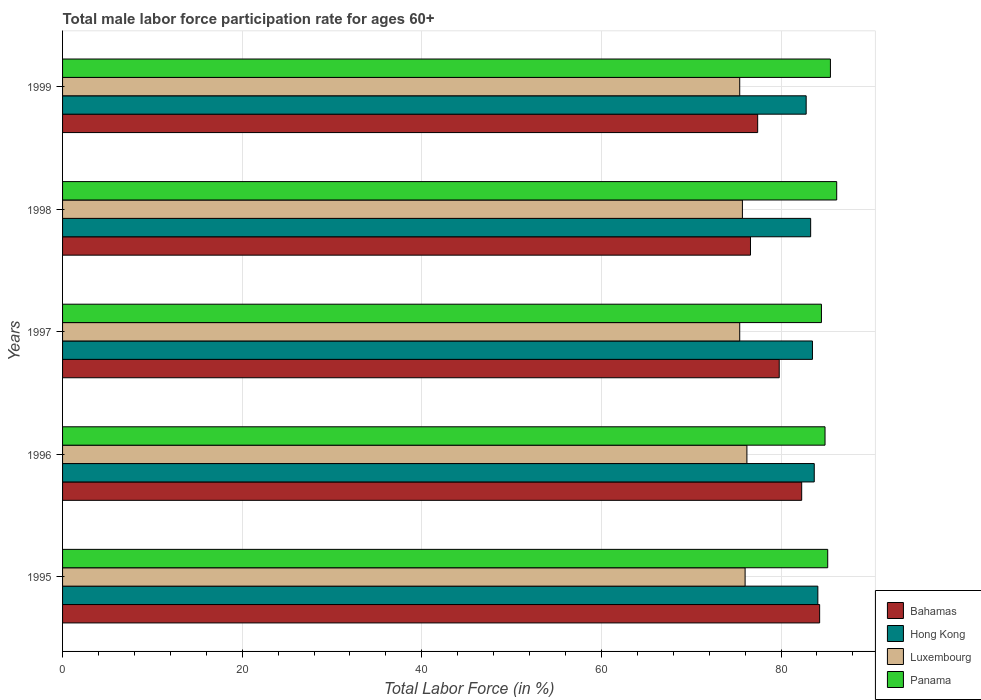How many different coloured bars are there?
Make the answer very short. 4. How many groups of bars are there?
Your answer should be very brief. 5. What is the label of the 2nd group of bars from the top?
Give a very brief answer. 1998. In how many cases, is the number of bars for a given year not equal to the number of legend labels?
Offer a very short reply. 0. What is the male labor force participation rate in Hong Kong in 1996?
Provide a short and direct response. 83.7. Across all years, what is the maximum male labor force participation rate in Hong Kong?
Offer a very short reply. 84.1. Across all years, what is the minimum male labor force participation rate in Luxembourg?
Make the answer very short. 75.4. What is the total male labor force participation rate in Panama in the graph?
Provide a short and direct response. 426.3. What is the difference between the male labor force participation rate in Bahamas in 1995 and the male labor force participation rate in Luxembourg in 1999?
Make the answer very short. 8.9. What is the average male labor force participation rate in Bahamas per year?
Ensure brevity in your answer.  80.08. In the year 1997, what is the difference between the male labor force participation rate in Luxembourg and male labor force participation rate in Bahamas?
Offer a terse response. -4.4. In how many years, is the male labor force participation rate in Panama greater than 44 %?
Provide a short and direct response. 5. What is the ratio of the male labor force participation rate in Luxembourg in 1995 to that in 1999?
Your answer should be compact. 1.01. Is the difference between the male labor force participation rate in Luxembourg in 1997 and 1998 greater than the difference between the male labor force participation rate in Bahamas in 1997 and 1998?
Your response must be concise. No. What is the difference between the highest and the second highest male labor force participation rate in Panama?
Your response must be concise. 0.7. What is the difference between the highest and the lowest male labor force participation rate in Bahamas?
Provide a succinct answer. 7.7. Is it the case that in every year, the sum of the male labor force participation rate in Luxembourg and male labor force participation rate in Hong Kong is greater than the sum of male labor force participation rate in Bahamas and male labor force participation rate in Panama?
Offer a terse response. Yes. What does the 1st bar from the top in 1995 represents?
Offer a very short reply. Panama. What does the 1st bar from the bottom in 1998 represents?
Offer a very short reply. Bahamas. Are all the bars in the graph horizontal?
Offer a very short reply. Yes. How many years are there in the graph?
Provide a short and direct response. 5. What is the difference between two consecutive major ticks on the X-axis?
Your response must be concise. 20. Does the graph contain any zero values?
Give a very brief answer. No. Does the graph contain grids?
Your answer should be very brief. Yes. Where does the legend appear in the graph?
Ensure brevity in your answer.  Bottom right. What is the title of the graph?
Offer a very short reply. Total male labor force participation rate for ages 60+. Does "Sweden" appear as one of the legend labels in the graph?
Give a very brief answer. No. What is the label or title of the X-axis?
Provide a succinct answer. Total Labor Force (in %). What is the Total Labor Force (in %) of Bahamas in 1995?
Keep it short and to the point. 84.3. What is the Total Labor Force (in %) in Hong Kong in 1995?
Offer a terse response. 84.1. What is the Total Labor Force (in %) of Panama in 1995?
Your answer should be compact. 85.2. What is the Total Labor Force (in %) of Bahamas in 1996?
Make the answer very short. 82.3. What is the Total Labor Force (in %) of Hong Kong in 1996?
Ensure brevity in your answer.  83.7. What is the Total Labor Force (in %) of Luxembourg in 1996?
Provide a succinct answer. 76.2. What is the Total Labor Force (in %) in Panama in 1996?
Make the answer very short. 84.9. What is the Total Labor Force (in %) in Bahamas in 1997?
Offer a terse response. 79.8. What is the Total Labor Force (in %) of Hong Kong in 1997?
Your answer should be compact. 83.5. What is the Total Labor Force (in %) in Luxembourg in 1997?
Your answer should be compact. 75.4. What is the Total Labor Force (in %) in Panama in 1997?
Your answer should be very brief. 84.5. What is the Total Labor Force (in %) of Bahamas in 1998?
Provide a succinct answer. 76.6. What is the Total Labor Force (in %) of Hong Kong in 1998?
Keep it short and to the point. 83.3. What is the Total Labor Force (in %) in Luxembourg in 1998?
Your response must be concise. 75.7. What is the Total Labor Force (in %) in Panama in 1998?
Ensure brevity in your answer.  86.2. What is the Total Labor Force (in %) in Bahamas in 1999?
Offer a terse response. 77.4. What is the Total Labor Force (in %) in Hong Kong in 1999?
Provide a short and direct response. 82.8. What is the Total Labor Force (in %) in Luxembourg in 1999?
Provide a short and direct response. 75.4. What is the Total Labor Force (in %) in Panama in 1999?
Ensure brevity in your answer.  85.5. Across all years, what is the maximum Total Labor Force (in %) of Bahamas?
Offer a very short reply. 84.3. Across all years, what is the maximum Total Labor Force (in %) of Hong Kong?
Your answer should be very brief. 84.1. Across all years, what is the maximum Total Labor Force (in %) in Luxembourg?
Your response must be concise. 76.2. Across all years, what is the maximum Total Labor Force (in %) in Panama?
Provide a succinct answer. 86.2. Across all years, what is the minimum Total Labor Force (in %) in Bahamas?
Provide a short and direct response. 76.6. Across all years, what is the minimum Total Labor Force (in %) in Hong Kong?
Offer a terse response. 82.8. Across all years, what is the minimum Total Labor Force (in %) in Luxembourg?
Give a very brief answer. 75.4. Across all years, what is the minimum Total Labor Force (in %) of Panama?
Provide a short and direct response. 84.5. What is the total Total Labor Force (in %) in Bahamas in the graph?
Provide a short and direct response. 400.4. What is the total Total Labor Force (in %) in Hong Kong in the graph?
Ensure brevity in your answer.  417.4. What is the total Total Labor Force (in %) in Luxembourg in the graph?
Your response must be concise. 378.7. What is the total Total Labor Force (in %) in Panama in the graph?
Keep it short and to the point. 426.3. What is the difference between the Total Labor Force (in %) of Panama in 1995 and that in 1996?
Make the answer very short. 0.3. What is the difference between the Total Labor Force (in %) of Bahamas in 1995 and that in 1997?
Give a very brief answer. 4.5. What is the difference between the Total Labor Force (in %) of Panama in 1995 and that in 1997?
Provide a succinct answer. 0.7. What is the difference between the Total Labor Force (in %) in Hong Kong in 1995 and that in 1998?
Provide a succinct answer. 0.8. What is the difference between the Total Labor Force (in %) of Bahamas in 1995 and that in 1999?
Provide a short and direct response. 6.9. What is the difference between the Total Labor Force (in %) in Hong Kong in 1995 and that in 1999?
Offer a very short reply. 1.3. What is the difference between the Total Labor Force (in %) of Panama in 1995 and that in 1999?
Keep it short and to the point. -0.3. What is the difference between the Total Labor Force (in %) in Luxembourg in 1996 and that in 1997?
Keep it short and to the point. 0.8. What is the difference between the Total Labor Force (in %) in Panama in 1996 and that in 1997?
Keep it short and to the point. 0.4. What is the difference between the Total Labor Force (in %) in Bahamas in 1996 and that in 1998?
Give a very brief answer. 5.7. What is the difference between the Total Labor Force (in %) in Luxembourg in 1996 and that in 1998?
Your answer should be compact. 0.5. What is the difference between the Total Labor Force (in %) in Panama in 1996 and that in 1998?
Make the answer very short. -1.3. What is the difference between the Total Labor Force (in %) in Panama in 1996 and that in 1999?
Your answer should be very brief. -0.6. What is the difference between the Total Labor Force (in %) in Bahamas in 1997 and that in 1998?
Your response must be concise. 3.2. What is the difference between the Total Labor Force (in %) of Hong Kong in 1997 and that in 1999?
Provide a short and direct response. 0.7. What is the difference between the Total Labor Force (in %) in Luxembourg in 1997 and that in 1999?
Make the answer very short. 0. What is the difference between the Total Labor Force (in %) of Bahamas in 1998 and that in 1999?
Offer a very short reply. -0.8. What is the difference between the Total Labor Force (in %) in Hong Kong in 1998 and that in 1999?
Ensure brevity in your answer.  0.5. What is the difference between the Total Labor Force (in %) of Bahamas in 1995 and the Total Labor Force (in %) of Hong Kong in 1996?
Keep it short and to the point. 0.6. What is the difference between the Total Labor Force (in %) in Bahamas in 1995 and the Total Labor Force (in %) in Luxembourg in 1996?
Provide a succinct answer. 8.1. What is the difference between the Total Labor Force (in %) in Bahamas in 1995 and the Total Labor Force (in %) in Panama in 1996?
Your answer should be very brief. -0.6. What is the difference between the Total Labor Force (in %) of Hong Kong in 1995 and the Total Labor Force (in %) of Luxembourg in 1996?
Your response must be concise. 7.9. What is the difference between the Total Labor Force (in %) in Bahamas in 1995 and the Total Labor Force (in %) in Hong Kong in 1997?
Provide a succinct answer. 0.8. What is the difference between the Total Labor Force (in %) of Bahamas in 1995 and the Total Labor Force (in %) of Luxembourg in 1997?
Provide a succinct answer. 8.9. What is the difference between the Total Labor Force (in %) in Hong Kong in 1995 and the Total Labor Force (in %) in Panama in 1997?
Make the answer very short. -0.4. What is the difference between the Total Labor Force (in %) in Bahamas in 1995 and the Total Labor Force (in %) in Hong Kong in 1998?
Provide a succinct answer. 1. What is the difference between the Total Labor Force (in %) of Bahamas in 1995 and the Total Labor Force (in %) of Panama in 1998?
Keep it short and to the point. -1.9. What is the difference between the Total Labor Force (in %) of Hong Kong in 1995 and the Total Labor Force (in %) of Panama in 1998?
Give a very brief answer. -2.1. What is the difference between the Total Labor Force (in %) of Luxembourg in 1995 and the Total Labor Force (in %) of Panama in 1998?
Make the answer very short. -10.2. What is the difference between the Total Labor Force (in %) of Hong Kong in 1995 and the Total Labor Force (in %) of Panama in 1999?
Keep it short and to the point. -1.4. What is the difference between the Total Labor Force (in %) in Bahamas in 1996 and the Total Labor Force (in %) in Panama in 1997?
Ensure brevity in your answer.  -2.2. What is the difference between the Total Labor Force (in %) in Hong Kong in 1996 and the Total Labor Force (in %) in Luxembourg in 1997?
Provide a succinct answer. 8.3. What is the difference between the Total Labor Force (in %) of Hong Kong in 1996 and the Total Labor Force (in %) of Panama in 1997?
Ensure brevity in your answer.  -0.8. What is the difference between the Total Labor Force (in %) in Luxembourg in 1996 and the Total Labor Force (in %) in Panama in 1997?
Ensure brevity in your answer.  -8.3. What is the difference between the Total Labor Force (in %) in Bahamas in 1996 and the Total Labor Force (in %) in Hong Kong in 1998?
Give a very brief answer. -1. What is the difference between the Total Labor Force (in %) of Bahamas in 1996 and the Total Labor Force (in %) of Luxembourg in 1998?
Your response must be concise. 6.6. What is the difference between the Total Labor Force (in %) in Hong Kong in 1996 and the Total Labor Force (in %) in Panama in 1998?
Your response must be concise. -2.5. What is the difference between the Total Labor Force (in %) in Luxembourg in 1996 and the Total Labor Force (in %) in Panama in 1998?
Your response must be concise. -10. What is the difference between the Total Labor Force (in %) of Bahamas in 1996 and the Total Labor Force (in %) of Panama in 1999?
Keep it short and to the point. -3.2. What is the difference between the Total Labor Force (in %) of Hong Kong in 1996 and the Total Labor Force (in %) of Luxembourg in 1999?
Make the answer very short. 8.3. What is the difference between the Total Labor Force (in %) of Bahamas in 1997 and the Total Labor Force (in %) of Hong Kong in 1998?
Your answer should be compact. -3.5. What is the difference between the Total Labor Force (in %) of Bahamas in 1997 and the Total Labor Force (in %) of Panama in 1998?
Provide a short and direct response. -6.4. What is the difference between the Total Labor Force (in %) of Bahamas in 1997 and the Total Labor Force (in %) of Hong Kong in 1999?
Ensure brevity in your answer.  -3. What is the difference between the Total Labor Force (in %) of Bahamas in 1997 and the Total Labor Force (in %) of Luxembourg in 1999?
Offer a terse response. 4.4. What is the difference between the Total Labor Force (in %) of Hong Kong in 1998 and the Total Labor Force (in %) of Panama in 1999?
Offer a very short reply. -2.2. What is the difference between the Total Labor Force (in %) of Luxembourg in 1998 and the Total Labor Force (in %) of Panama in 1999?
Keep it short and to the point. -9.8. What is the average Total Labor Force (in %) in Bahamas per year?
Ensure brevity in your answer.  80.08. What is the average Total Labor Force (in %) of Hong Kong per year?
Your response must be concise. 83.48. What is the average Total Labor Force (in %) in Luxembourg per year?
Ensure brevity in your answer.  75.74. What is the average Total Labor Force (in %) in Panama per year?
Your response must be concise. 85.26. In the year 1995, what is the difference between the Total Labor Force (in %) of Bahamas and Total Labor Force (in %) of Hong Kong?
Your answer should be compact. 0.2. In the year 1995, what is the difference between the Total Labor Force (in %) in Bahamas and Total Labor Force (in %) in Luxembourg?
Give a very brief answer. 8.3. In the year 1995, what is the difference between the Total Labor Force (in %) in Bahamas and Total Labor Force (in %) in Panama?
Your answer should be very brief. -0.9. In the year 1995, what is the difference between the Total Labor Force (in %) in Hong Kong and Total Labor Force (in %) in Luxembourg?
Your answer should be compact. 8.1. In the year 1995, what is the difference between the Total Labor Force (in %) of Hong Kong and Total Labor Force (in %) of Panama?
Ensure brevity in your answer.  -1.1. In the year 1995, what is the difference between the Total Labor Force (in %) of Luxembourg and Total Labor Force (in %) of Panama?
Provide a succinct answer. -9.2. In the year 1996, what is the difference between the Total Labor Force (in %) of Bahamas and Total Labor Force (in %) of Hong Kong?
Offer a very short reply. -1.4. In the year 1996, what is the difference between the Total Labor Force (in %) of Bahamas and Total Labor Force (in %) of Panama?
Keep it short and to the point. -2.6. In the year 1997, what is the difference between the Total Labor Force (in %) in Bahamas and Total Labor Force (in %) in Hong Kong?
Provide a succinct answer. -3.7. In the year 1998, what is the difference between the Total Labor Force (in %) of Bahamas and Total Labor Force (in %) of Panama?
Your response must be concise. -9.6. In the year 1998, what is the difference between the Total Labor Force (in %) of Hong Kong and Total Labor Force (in %) of Panama?
Provide a short and direct response. -2.9. In the year 1998, what is the difference between the Total Labor Force (in %) of Luxembourg and Total Labor Force (in %) of Panama?
Offer a terse response. -10.5. In the year 1999, what is the difference between the Total Labor Force (in %) of Luxembourg and Total Labor Force (in %) of Panama?
Your response must be concise. -10.1. What is the ratio of the Total Labor Force (in %) in Bahamas in 1995 to that in 1996?
Ensure brevity in your answer.  1.02. What is the ratio of the Total Labor Force (in %) in Hong Kong in 1995 to that in 1996?
Give a very brief answer. 1. What is the ratio of the Total Labor Force (in %) in Bahamas in 1995 to that in 1997?
Make the answer very short. 1.06. What is the ratio of the Total Labor Force (in %) of Hong Kong in 1995 to that in 1997?
Your answer should be compact. 1.01. What is the ratio of the Total Labor Force (in %) in Luxembourg in 1995 to that in 1997?
Your answer should be very brief. 1.01. What is the ratio of the Total Labor Force (in %) of Panama in 1995 to that in 1997?
Offer a terse response. 1.01. What is the ratio of the Total Labor Force (in %) in Bahamas in 1995 to that in 1998?
Offer a very short reply. 1.1. What is the ratio of the Total Labor Force (in %) of Hong Kong in 1995 to that in 1998?
Make the answer very short. 1.01. What is the ratio of the Total Labor Force (in %) of Panama in 1995 to that in 1998?
Offer a terse response. 0.99. What is the ratio of the Total Labor Force (in %) in Bahamas in 1995 to that in 1999?
Give a very brief answer. 1.09. What is the ratio of the Total Labor Force (in %) in Hong Kong in 1995 to that in 1999?
Provide a short and direct response. 1.02. What is the ratio of the Total Labor Force (in %) in Bahamas in 1996 to that in 1997?
Provide a short and direct response. 1.03. What is the ratio of the Total Labor Force (in %) in Hong Kong in 1996 to that in 1997?
Your answer should be compact. 1. What is the ratio of the Total Labor Force (in %) of Luxembourg in 1996 to that in 1997?
Keep it short and to the point. 1.01. What is the ratio of the Total Labor Force (in %) of Bahamas in 1996 to that in 1998?
Provide a succinct answer. 1.07. What is the ratio of the Total Labor Force (in %) in Hong Kong in 1996 to that in 1998?
Offer a terse response. 1. What is the ratio of the Total Labor Force (in %) in Luxembourg in 1996 to that in 1998?
Your answer should be compact. 1.01. What is the ratio of the Total Labor Force (in %) in Panama in 1996 to that in 1998?
Provide a succinct answer. 0.98. What is the ratio of the Total Labor Force (in %) of Bahamas in 1996 to that in 1999?
Ensure brevity in your answer.  1.06. What is the ratio of the Total Labor Force (in %) of Hong Kong in 1996 to that in 1999?
Offer a terse response. 1.01. What is the ratio of the Total Labor Force (in %) of Luxembourg in 1996 to that in 1999?
Keep it short and to the point. 1.01. What is the ratio of the Total Labor Force (in %) of Panama in 1996 to that in 1999?
Give a very brief answer. 0.99. What is the ratio of the Total Labor Force (in %) in Bahamas in 1997 to that in 1998?
Offer a very short reply. 1.04. What is the ratio of the Total Labor Force (in %) of Panama in 1997 to that in 1998?
Your answer should be very brief. 0.98. What is the ratio of the Total Labor Force (in %) in Bahamas in 1997 to that in 1999?
Your answer should be very brief. 1.03. What is the ratio of the Total Labor Force (in %) in Hong Kong in 1997 to that in 1999?
Keep it short and to the point. 1.01. What is the ratio of the Total Labor Force (in %) in Panama in 1997 to that in 1999?
Your response must be concise. 0.99. What is the ratio of the Total Labor Force (in %) in Bahamas in 1998 to that in 1999?
Your response must be concise. 0.99. What is the ratio of the Total Labor Force (in %) in Hong Kong in 1998 to that in 1999?
Your response must be concise. 1.01. What is the ratio of the Total Labor Force (in %) in Luxembourg in 1998 to that in 1999?
Your response must be concise. 1. What is the ratio of the Total Labor Force (in %) in Panama in 1998 to that in 1999?
Make the answer very short. 1.01. What is the difference between the highest and the second highest Total Labor Force (in %) in Bahamas?
Your answer should be compact. 2. What is the difference between the highest and the second highest Total Labor Force (in %) in Hong Kong?
Offer a very short reply. 0.4. What is the difference between the highest and the second highest Total Labor Force (in %) in Luxembourg?
Your answer should be very brief. 0.2. What is the difference between the highest and the lowest Total Labor Force (in %) in Bahamas?
Provide a succinct answer. 7.7. What is the difference between the highest and the lowest Total Labor Force (in %) of Panama?
Your answer should be very brief. 1.7. 